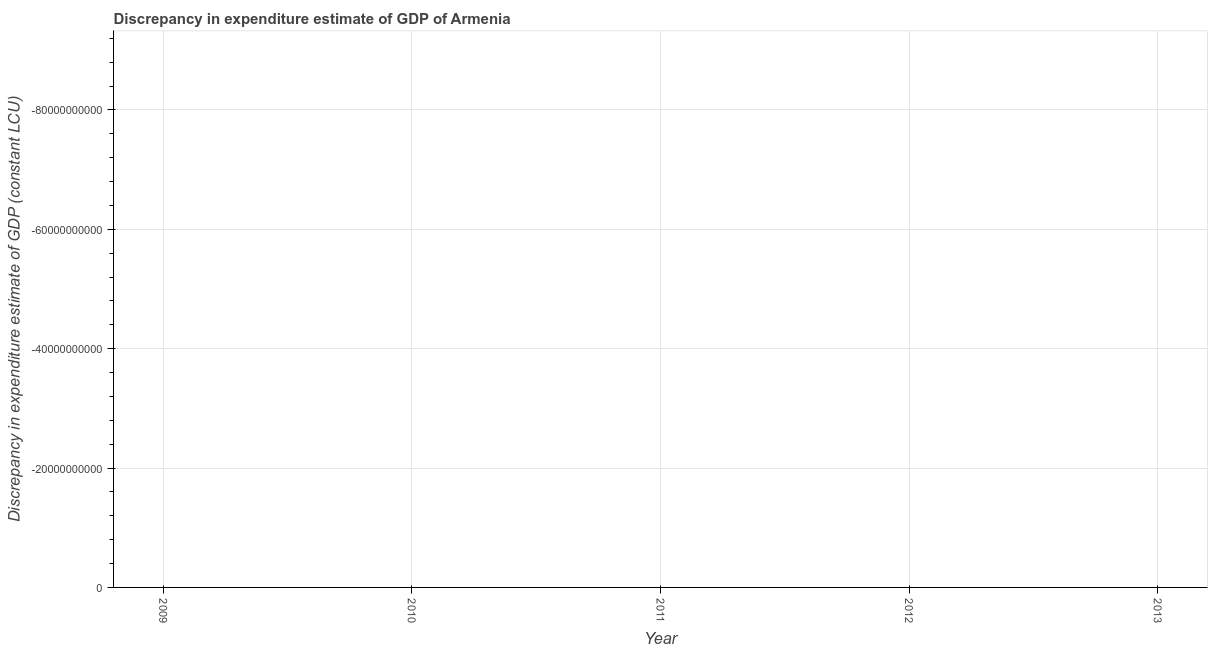Across all years, what is the minimum discrepancy in expenditure estimate of gdp?
Keep it short and to the point. 0. What is the sum of the discrepancy in expenditure estimate of gdp?
Keep it short and to the point. 0. In how many years, is the discrepancy in expenditure estimate of gdp greater than -28000000000 LCU?
Your answer should be compact. 0. In how many years, is the discrepancy in expenditure estimate of gdp greater than the average discrepancy in expenditure estimate of gdp taken over all years?
Make the answer very short. 0. How many lines are there?
Offer a terse response. 0. What is the title of the graph?
Provide a short and direct response. Discrepancy in expenditure estimate of GDP of Armenia. What is the label or title of the Y-axis?
Provide a succinct answer. Discrepancy in expenditure estimate of GDP (constant LCU). What is the Discrepancy in expenditure estimate of GDP (constant LCU) in 2009?
Your response must be concise. 0. What is the Discrepancy in expenditure estimate of GDP (constant LCU) of 2012?
Ensure brevity in your answer.  0. What is the Discrepancy in expenditure estimate of GDP (constant LCU) of 2013?
Your answer should be very brief. 0. 